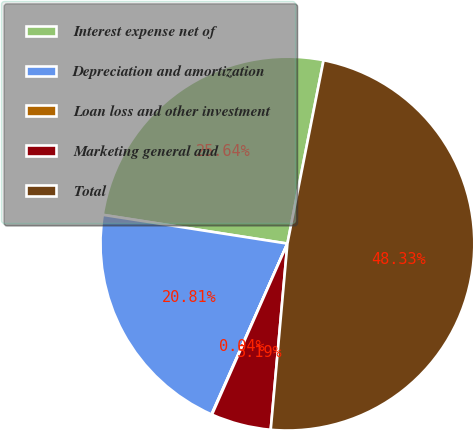Convert chart to OTSL. <chart><loc_0><loc_0><loc_500><loc_500><pie_chart><fcel>Interest expense net of<fcel>Depreciation and amortization<fcel>Loan loss and other investment<fcel>Marketing general and<fcel>Total<nl><fcel>25.64%<fcel>20.81%<fcel>0.04%<fcel>5.19%<fcel>48.33%<nl></chart> 